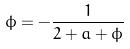<formula> <loc_0><loc_0><loc_500><loc_500>\phi = - \frac { 1 } { 2 + a + \phi }</formula> 